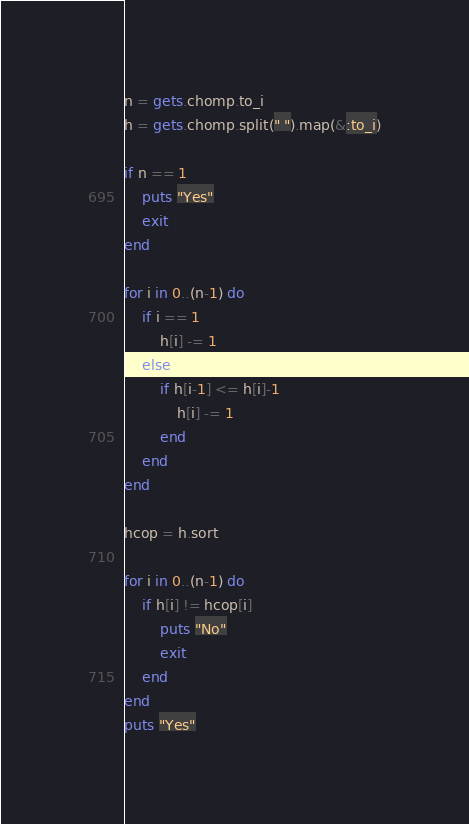Convert code to text. <code><loc_0><loc_0><loc_500><loc_500><_Ruby_>n = gets.chomp.to_i
h = gets.chomp.split(" ").map(&:to_i)
 
if n == 1
    puts "Yes"
    exit
end

for i in 0..(n-1) do
    if i == 1
        h[i] -= 1
    else
        if h[i-1] <= h[i]-1
            h[i] -= 1
        end
    end
end

hcop = h.sort

for i in 0..(n-1) do 
    if h[i] != hcop[i]
        puts "No"
        exit
    end
end
puts "Yes"

</code> 